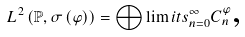<formula> <loc_0><loc_0><loc_500><loc_500>L ^ { 2 } \left ( \mathbb { P } , \sigma \left ( \varphi \right ) \right ) = \bigoplus \lim i t s _ { n = 0 } ^ { \infty } C _ { n } ^ { \varphi } \text {,}</formula> 